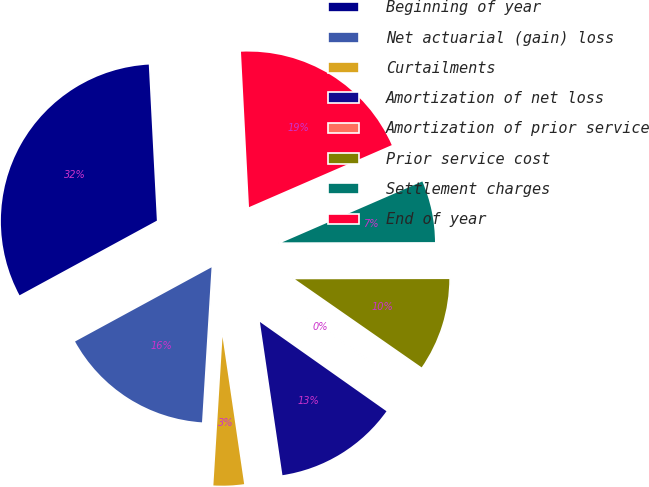Convert chart. <chart><loc_0><loc_0><loc_500><loc_500><pie_chart><fcel>Beginning of year<fcel>Net actuarial (gain) loss<fcel>Curtailments<fcel>Amortization of net loss<fcel>Amortization of prior service<fcel>Prior service cost<fcel>Settlement charges<fcel>End of year<nl><fcel>32.1%<fcel>16.1%<fcel>3.3%<fcel>12.9%<fcel>0.1%<fcel>9.7%<fcel>6.5%<fcel>19.3%<nl></chart> 